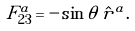Convert formula to latex. <formula><loc_0><loc_0><loc_500><loc_500>F _ { 2 3 } ^ { a } = - \sin \theta \, \hat { r } ^ { a } .</formula> 